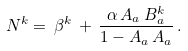<formula> <loc_0><loc_0><loc_500><loc_500>N ^ { k } = \, { \beta } ^ { k } \, + \, \frac { \alpha \, A _ { a } \, B _ { a } ^ { k } } { 1 - A _ { a } \, A _ { a } } \, .</formula> 